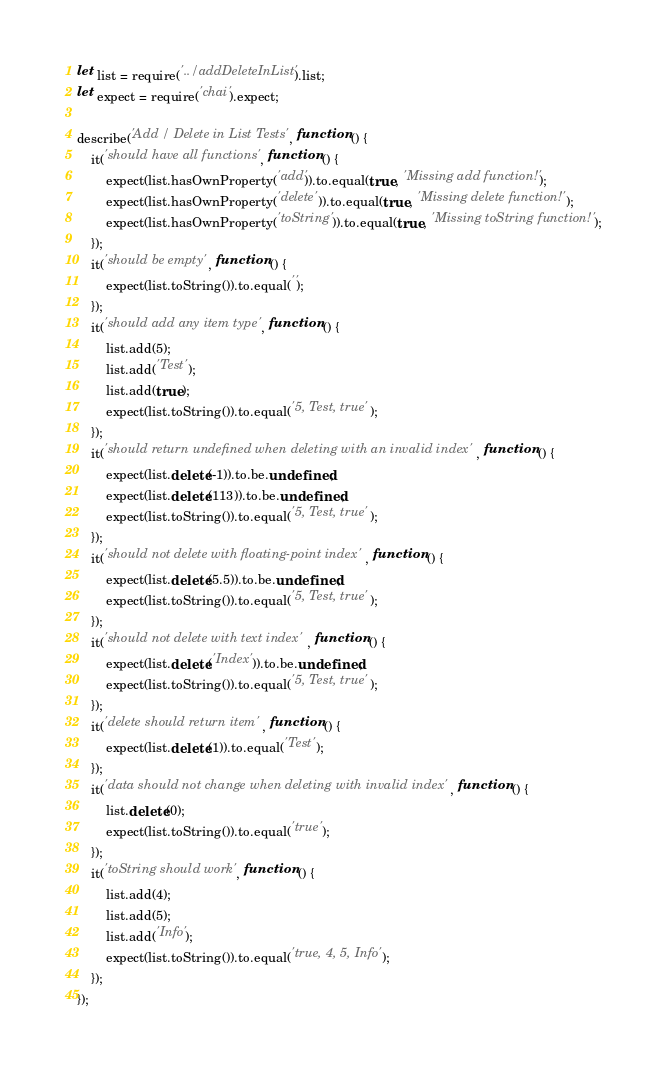<code> <loc_0><loc_0><loc_500><loc_500><_JavaScript_>let list = require('../addDeleteInList').list;
let expect = require('chai').expect;

describe('Add / Delete in List Tests', function () {
    it('should have all functions', function () {
        expect(list.hasOwnProperty('add')).to.equal(true, 'Missing add function!');
        expect(list.hasOwnProperty('delete')).to.equal(true, 'Missing delete function!');
        expect(list.hasOwnProperty('toString')).to.equal(true, 'Missing toString function!');
    });
    it('should be empty', function () {
        expect(list.toString()).to.equal('');
    });
    it('should add any item type', function () {
        list.add(5);
        list.add('Test');
        list.add(true);
        expect(list.toString()).to.equal('5, Test, true');
    });
    it('should return undefined when deleting with an invalid index', function () {
        expect(list.delete(-1)).to.be.undefined;
        expect(list.delete(113)).to.be.undefined;
        expect(list.toString()).to.equal('5, Test, true');
    });
    it('should not delete with floating-point index', function () {
        expect(list.delete(5.5)).to.be.undefined;
        expect(list.toString()).to.equal('5, Test, true');
    });
    it('should not delete with text index', function () {
        expect(list.delete('Index')).to.be.undefined;
        expect(list.toString()).to.equal('5, Test, true');
    });
    it('delete should return item', function () {
        expect(list.delete(1)).to.equal('Test');
    });
    it('data should not change when deleting with invalid index', function () {
        list.delete(0);
        expect(list.toString()).to.equal('true');
    });
    it('toString should work', function () {
        list.add(4);
        list.add(5);
        list.add('Info');
        expect(list.toString()).to.equal('true, 4, 5, Info');
    });
});</code> 